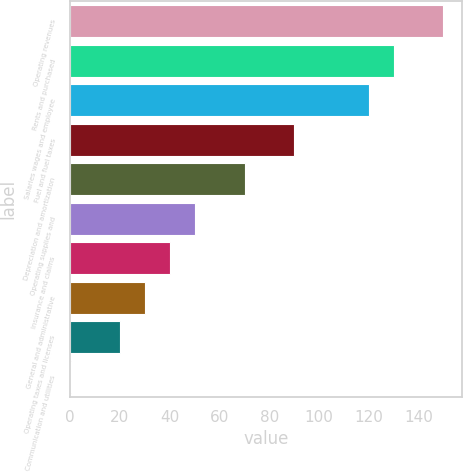Convert chart. <chart><loc_0><loc_0><loc_500><loc_500><bar_chart><fcel>Operating revenues<fcel>Rents and purchased<fcel>Salaries wages and employee<fcel>Fuel and fuel taxes<fcel>Depreciation and amortization<fcel>Operating supplies and<fcel>Insurance and claims<fcel>General and administrative<fcel>Operating taxes and licenses<fcel>Communication and utilities<nl><fcel>149.85<fcel>129.91<fcel>119.94<fcel>90.03<fcel>70.09<fcel>50.15<fcel>40.18<fcel>30.21<fcel>20.24<fcel>0.3<nl></chart> 